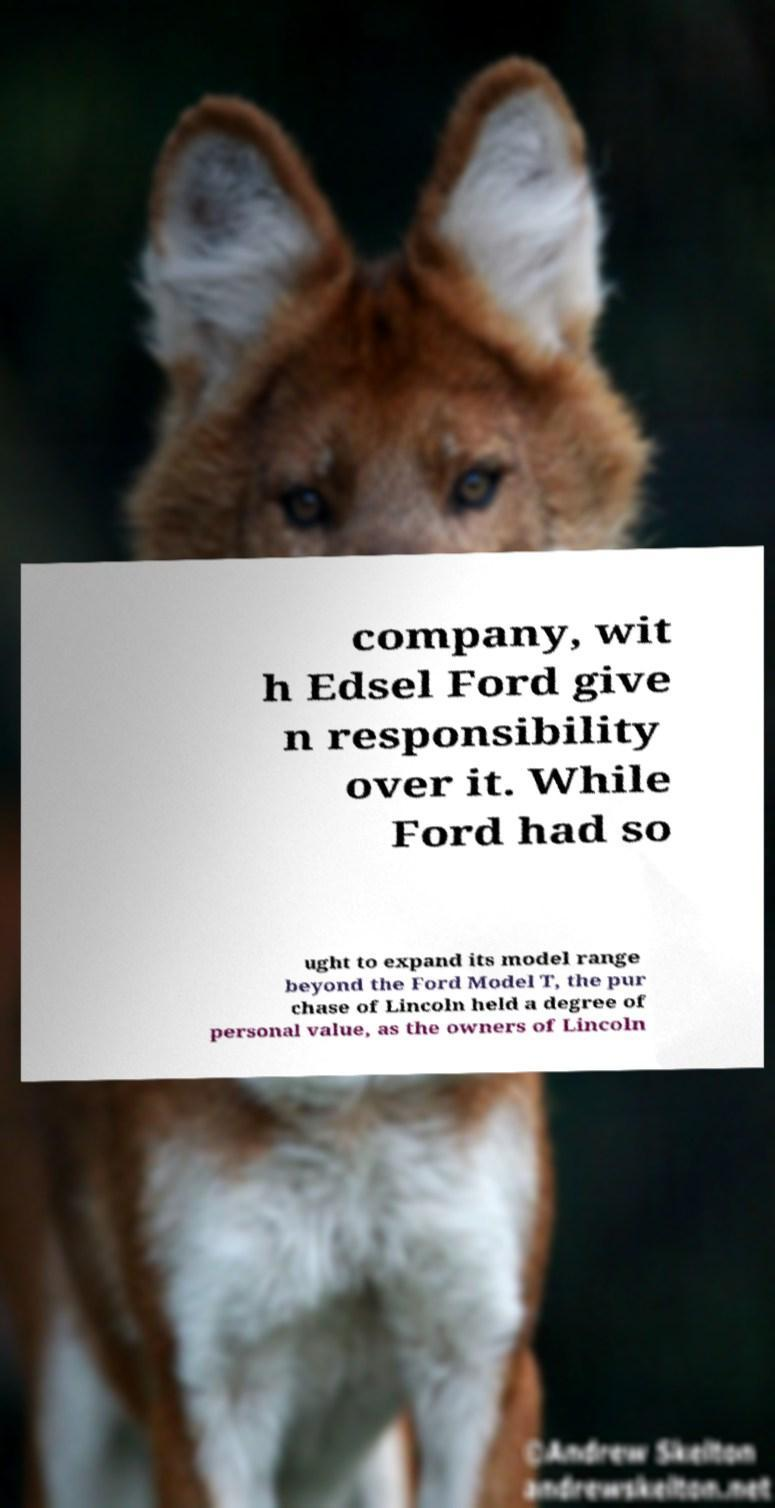Can you read and provide the text displayed in the image?This photo seems to have some interesting text. Can you extract and type it out for me? company, wit h Edsel Ford give n responsibility over it. While Ford had so ught to expand its model range beyond the Ford Model T, the pur chase of Lincoln held a degree of personal value, as the owners of Lincoln 